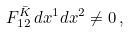<formula> <loc_0><loc_0><loc_500><loc_500>F _ { 1 2 } ^ { \bar { K } } \, d x ^ { 1 } d x ^ { 2 } \neq 0 \, ,</formula> 